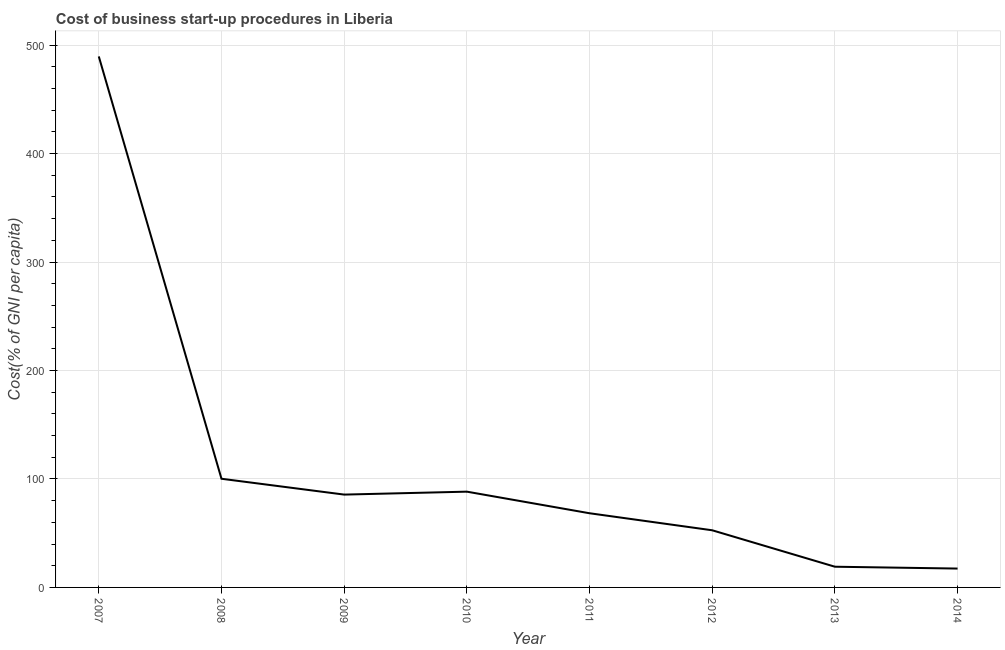What is the cost of business startup procedures in 2008?
Your response must be concise. 100.2. Across all years, what is the maximum cost of business startup procedures?
Keep it short and to the point. 489.6. In which year was the cost of business startup procedures maximum?
Offer a very short reply. 2007. In which year was the cost of business startup procedures minimum?
Your answer should be compact. 2014. What is the sum of the cost of business startup procedures?
Your answer should be very brief. 921.3. What is the difference between the cost of business startup procedures in 2008 and 2009?
Offer a very short reply. 14.6. What is the average cost of business startup procedures per year?
Offer a terse response. 115.16. In how many years, is the cost of business startup procedures greater than 300 %?
Give a very brief answer. 1. What is the ratio of the cost of business startup procedures in 2007 to that in 2009?
Offer a terse response. 5.72. What is the difference between the highest and the second highest cost of business startup procedures?
Ensure brevity in your answer.  389.4. Is the sum of the cost of business startup procedures in 2009 and 2013 greater than the maximum cost of business startup procedures across all years?
Ensure brevity in your answer.  No. What is the difference between the highest and the lowest cost of business startup procedures?
Your response must be concise. 472.2. How many lines are there?
Provide a short and direct response. 1. How many years are there in the graph?
Provide a succinct answer. 8. Are the values on the major ticks of Y-axis written in scientific E-notation?
Your answer should be compact. No. What is the title of the graph?
Your answer should be compact. Cost of business start-up procedures in Liberia. What is the label or title of the Y-axis?
Your response must be concise. Cost(% of GNI per capita). What is the Cost(% of GNI per capita) in 2007?
Keep it short and to the point. 489.6. What is the Cost(% of GNI per capita) of 2008?
Offer a terse response. 100.2. What is the Cost(% of GNI per capita) in 2009?
Keep it short and to the point. 85.6. What is the Cost(% of GNI per capita) in 2010?
Your answer should be compact. 88.3. What is the Cost(% of GNI per capita) in 2011?
Your answer should be compact. 68.4. What is the Cost(% of GNI per capita) in 2012?
Give a very brief answer. 52.7. What is the Cost(% of GNI per capita) of 2013?
Keep it short and to the point. 19.1. What is the difference between the Cost(% of GNI per capita) in 2007 and 2008?
Provide a short and direct response. 389.4. What is the difference between the Cost(% of GNI per capita) in 2007 and 2009?
Offer a very short reply. 404. What is the difference between the Cost(% of GNI per capita) in 2007 and 2010?
Make the answer very short. 401.3. What is the difference between the Cost(% of GNI per capita) in 2007 and 2011?
Make the answer very short. 421.2. What is the difference between the Cost(% of GNI per capita) in 2007 and 2012?
Offer a terse response. 436.9. What is the difference between the Cost(% of GNI per capita) in 2007 and 2013?
Give a very brief answer. 470.5. What is the difference between the Cost(% of GNI per capita) in 2007 and 2014?
Ensure brevity in your answer.  472.2. What is the difference between the Cost(% of GNI per capita) in 2008 and 2010?
Your response must be concise. 11.9. What is the difference between the Cost(% of GNI per capita) in 2008 and 2011?
Keep it short and to the point. 31.8. What is the difference between the Cost(% of GNI per capita) in 2008 and 2012?
Provide a succinct answer. 47.5. What is the difference between the Cost(% of GNI per capita) in 2008 and 2013?
Make the answer very short. 81.1. What is the difference between the Cost(% of GNI per capita) in 2008 and 2014?
Your answer should be very brief. 82.8. What is the difference between the Cost(% of GNI per capita) in 2009 and 2011?
Keep it short and to the point. 17.2. What is the difference between the Cost(% of GNI per capita) in 2009 and 2012?
Your response must be concise. 32.9. What is the difference between the Cost(% of GNI per capita) in 2009 and 2013?
Your answer should be compact. 66.5. What is the difference between the Cost(% of GNI per capita) in 2009 and 2014?
Provide a succinct answer. 68.2. What is the difference between the Cost(% of GNI per capita) in 2010 and 2012?
Offer a terse response. 35.6. What is the difference between the Cost(% of GNI per capita) in 2010 and 2013?
Provide a short and direct response. 69.2. What is the difference between the Cost(% of GNI per capita) in 2010 and 2014?
Give a very brief answer. 70.9. What is the difference between the Cost(% of GNI per capita) in 2011 and 2012?
Offer a very short reply. 15.7. What is the difference between the Cost(% of GNI per capita) in 2011 and 2013?
Offer a terse response. 49.3. What is the difference between the Cost(% of GNI per capita) in 2012 and 2013?
Your answer should be very brief. 33.6. What is the difference between the Cost(% of GNI per capita) in 2012 and 2014?
Make the answer very short. 35.3. What is the difference between the Cost(% of GNI per capita) in 2013 and 2014?
Your answer should be compact. 1.7. What is the ratio of the Cost(% of GNI per capita) in 2007 to that in 2008?
Provide a succinct answer. 4.89. What is the ratio of the Cost(% of GNI per capita) in 2007 to that in 2009?
Your answer should be compact. 5.72. What is the ratio of the Cost(% of GNI per capita) in 2007 to that in 2010?
Give a very brief answer. 5.54. What is the ratio of the Cost(% of GNI per capita) in 2007 to that in 2011?
Offer a very short reply. 7.16. What is the ratio of the Cost(% of GNI per capita) in 2007 to that in 2012?
Provide a short and direct response. 9.29. What is the ratio of the Cost(% of GNI per capita) in 2007 to that in 2013?
Offer a terse response. 25.63. What is the ratio of the Cost(% of GNI per capita) in 2007 to that in 2014?
Keep it short and to the point. 28.14. What is the ratio of the Cost(% of GNI per capita) in 2008 to that in 2009?
Provide a succinct answer. 1.17. What is the ratio of the Cost(% of GNI per capita) in 2008 to that in 2010?
Keep it short and to the point. 1.14. What is the ratio of the Cost(% of GNI per capita) in 2008 to that in 2011?
Make the answer very short. 1.47. What is the ratio of the Cost(% of GNI per capita) in 2008 to that in 2012?
Your answer should be very brief. 1.9. What is the ratio of the Cost(% of GNI per capita) in 2008 to that in 2013?
Keep it short and to the point. 5.25. What is the ratio of the Cost(% of GNI per capita) in 2008 to that in 2014?
Offer a terse response. 5.76. What is the ratio of the Cost(% of GNI per capita) in 2009 to that in 2011?
Your answer should be compact. 1.25. What is the ratio of the Cost(% of GNI per capita) in 2009 to that in 2012?
Provide a short and direct response. 1.62. What is the ratio of the Cost(% of GNI per capita) in 2009 to that in 2013?
Provide a short and direct response. 4.48. What is the ratio of the Cost(% of GNI per capita) in 2009 to that in 2014?
Offer a very short reply. 4.92. What is the ratio of the Cost(% of GNI per capita) in 2010 to that in 2011?
Give a very brief answer. 1.29. What is the ratio of the Cost(% of GNI per capita) in 2010 to that in 2012?
Offer a terse response. 1.68. What is the ratio of the Cost(% of GNI per capita) in 2010 to that in 2013?
Your answer should be compact. 4.62. What is the ratio of the Cost(% of GNI per capita) in 2010 to that in 2014?
Give a very brief answer. 5.08. What is the ratio of the Cost(% of GNI per capita) in 2011 to that in 2012?
Your answer should be very brief. 1.3. What is the ratio of the Cost(% of GNI per capita) in 2011 to that in 2013?
Make the answer very short. 3.58. What is the ratio of the Cost(% of GNI per capita) in 2011 to that in 2014?
Your answer should be very brief. 3.93. What is the ratio of the Cost(% of GNI per capita) in 2012 to that in 2013?
Offer a terse response. 2.76. What is the ratio of the Cost(% of GNI per capita) in 2012 to that in 2014?
Ensure brevity in your answer.  3.03. What is the ratio of the Cost(% of GNI per capita) in 2013 to that in 2014?
Your answer should be very brief. 1.1. 